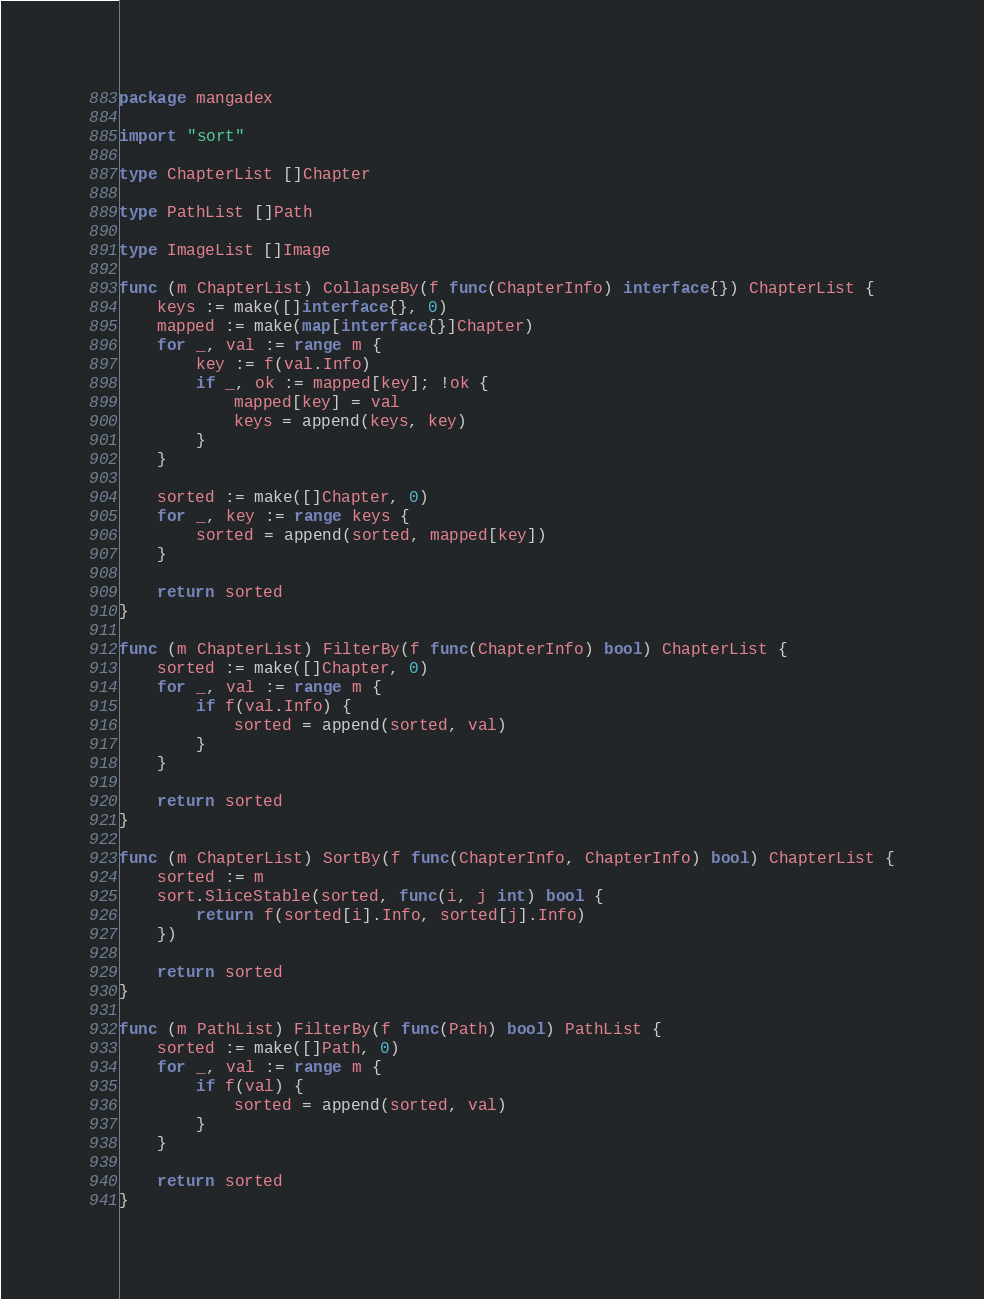<code> <loc_0><loc_0><loc_500><loc_500><_Go_>package mangadex

import "sort"

type ChapterList []Chapter

type PathList []Path

type ImageList []Image

func (m ChapterList) CollapseBy(f func(ChapterInfo) interface{}) ChapterList {
	keys := make([]interface{}, 0)
	mapped := make(map[interface{}]Chapter)
	for _, val := range m {
		key := f(val.Info)
		if _, ok := mapped[key]; !ok {
			mapped[key] = val
			keys = append(keys, key)
		}
	}

	sorted := make([]Chapter, 0)
	for _, key := range keys {
		sorted = append(sorted, mapped[key])
	}

	return sorted
}

func (m ChapterList) FilterBy(f func(ChapterInfo) bool) ChapterList {
	sorted := make([]Chapter, 0)
	for _, val := range m {
		if f(val.Info) {
			sorted = append(sorted, val)
		}
	}

	return sorted
}

func (m ChapterList) SortBy(f func(ChapterInfo, ChapterInfo) bool) ChapterList {
	sorted := m
	sort.SliceStable(sorted, func(i, j int) bool {
		return f(sorted[i].Info, sorted[j].Info)
	})

	return sorted
}

func (m PathList) FilterBy(f func(Path) bool) PathList {
	sorted := make([]Path, 0)
	for _, val := range m {
		if f(val) {
			sorted = append(sorted, val)
		}
	}

	return sorted
}
</code> 